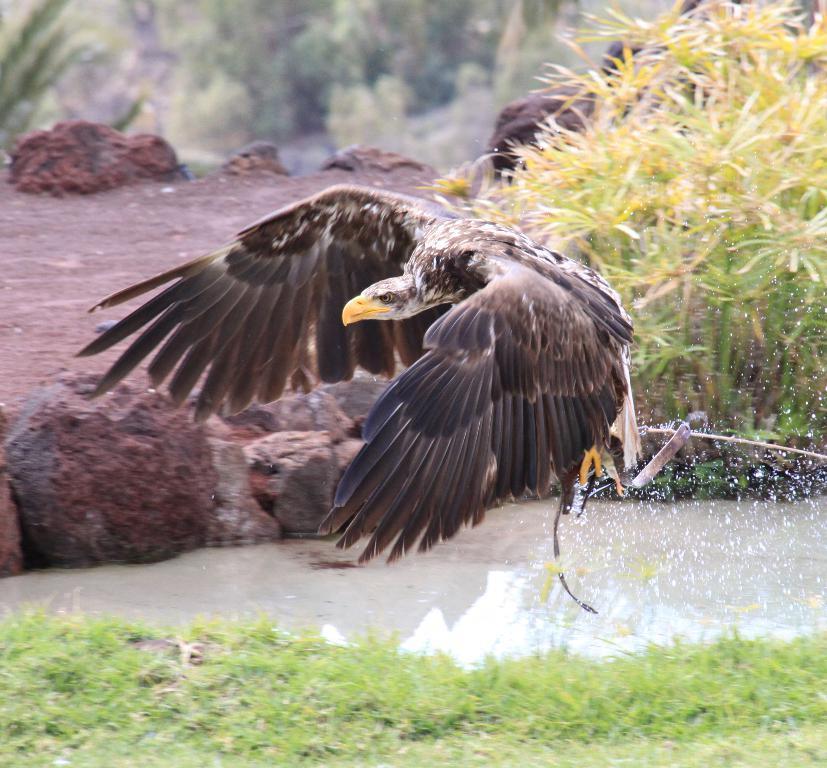Describe this image in one or two sentences. In this image I can see a black colour eagle, grass, water and in background I can see plants. I can also see this image is little bit blurry from background. 